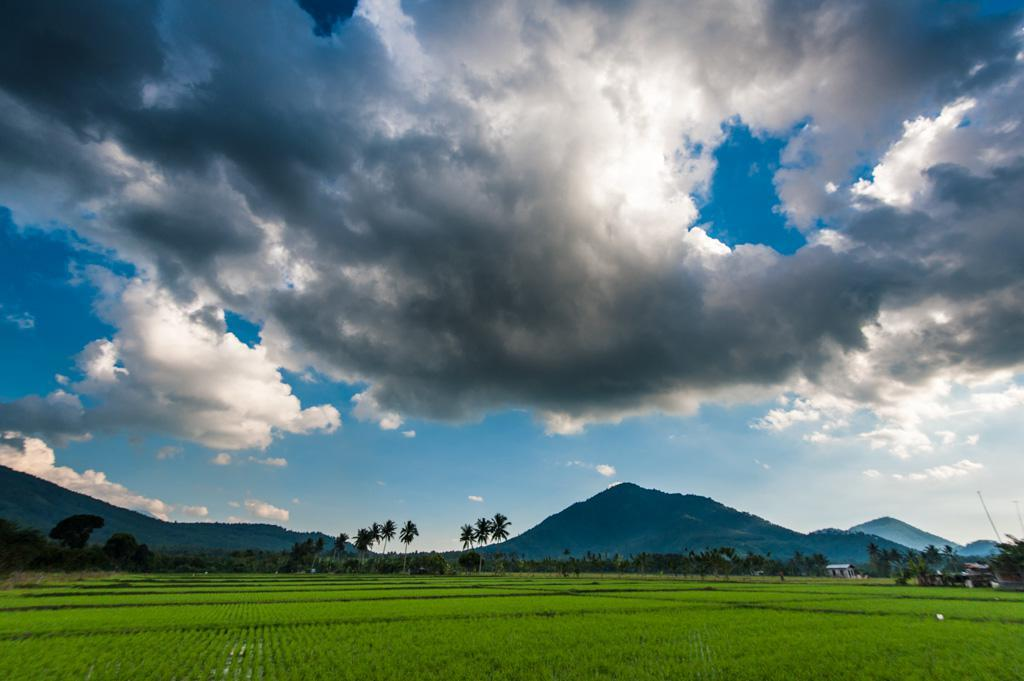What type of scenery is shown in the image? The image depicts a beautiful scenery. What can be seen growing in the image? There are crops in the image. What type of vegetation is present in the image? There are trees in the image. What geographical feature is visible in the background of the image? There are mountains in the image. What is visible in the sky in the image? There are clouds in the sky in the image. Can you see a flock of birds flying over the crops in the image? There is no mention of birds or a flock in the image, so we cannot confirm their presence. Is there a ring visible on the trees in the image? There is no ring present on the trees in the image. 